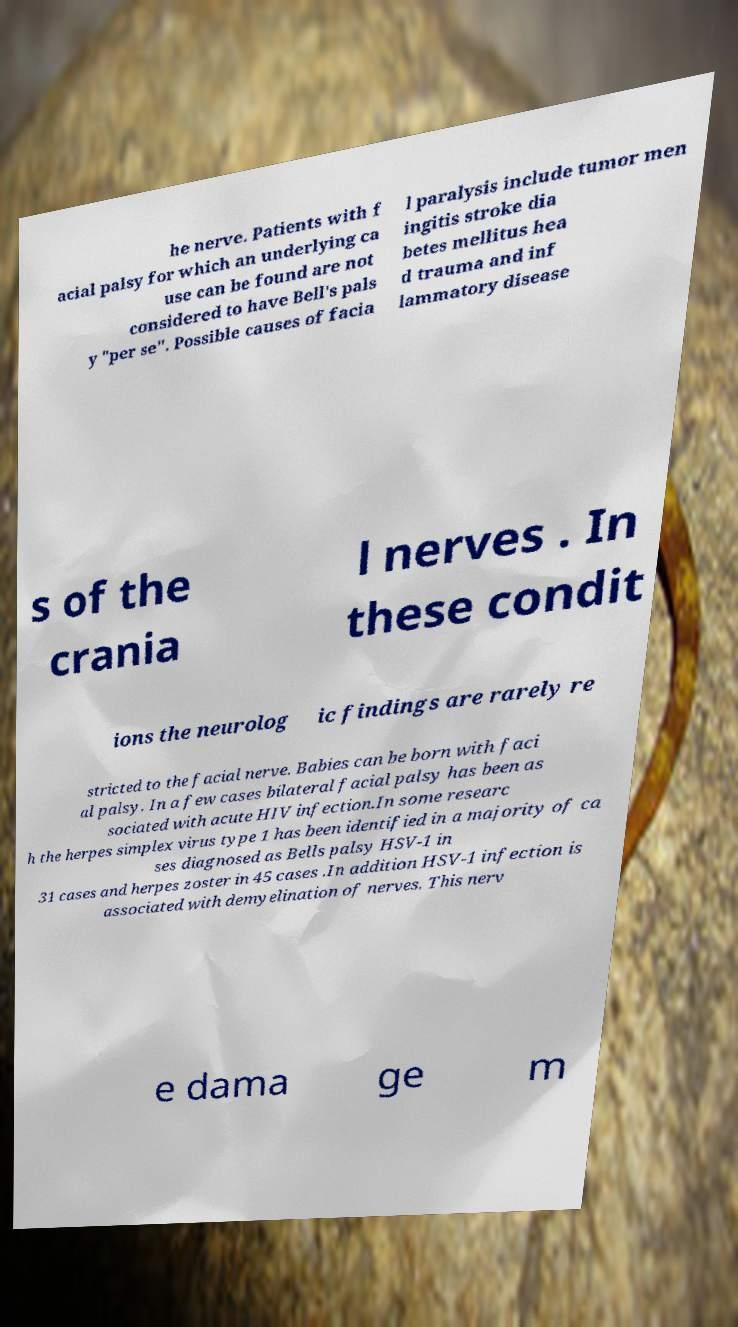Please read and relay the text visible in this image. What does it say? he nerve. Patients with f acial palsy for which an underlying ca use can be found are not considered to have Bell's pals y "per se". Possible causes of facia l paralysis include tumor men ingitis stroke dia betes mellitus hea d trauma and inf lammatory disease s of the crania l nerves . In these condit ions the neurolog ic findings are rarely re stricted to the facial nerve. Babies can be born with faci al palsy. In a few cases bilateral facial palsy has been as sociated with acute HIV infection.In some researc h the herpes simplex virus type 1 has been identified in a majority of ca ses diagnosed as Bells palsy HSV-1 in 31 cases and herpes zoster in 45 cases .In addition HSV-1 infection is associated with demyelination of nerves. This nerv e dama ge m 